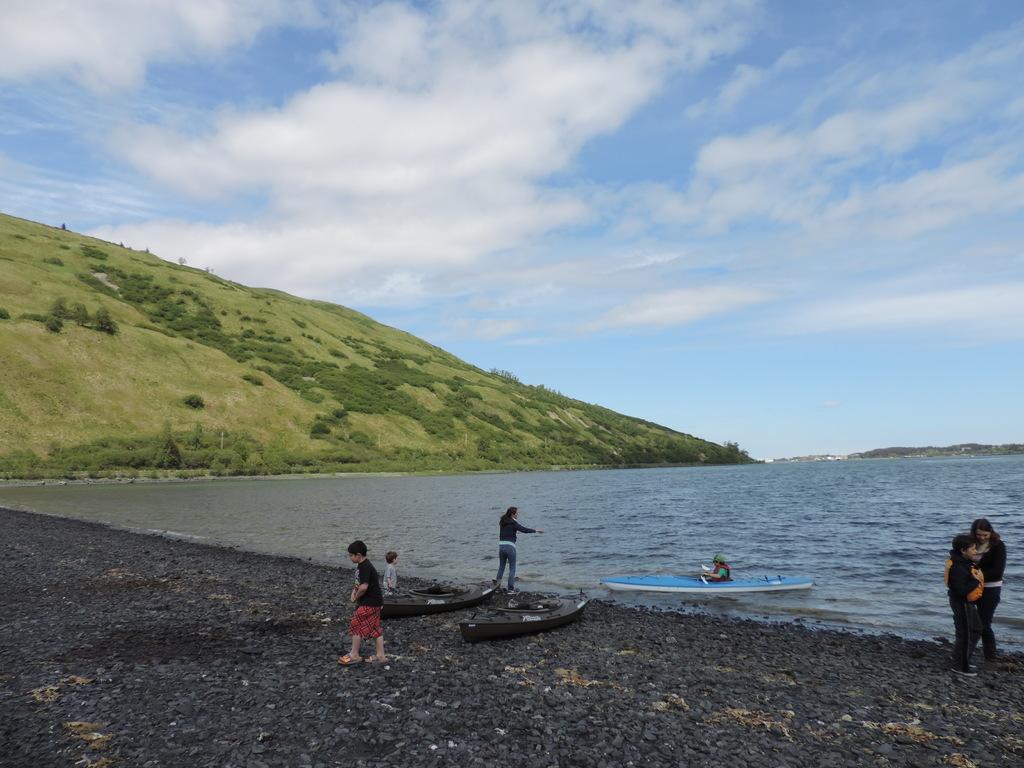Can you describe this image briefly? In the background we can see the hills, clouds in the sky, green grass and the thicket. In this picture we can see the people near the seashore and we can see the boats. We can see the water and a person sitting in a boat. 